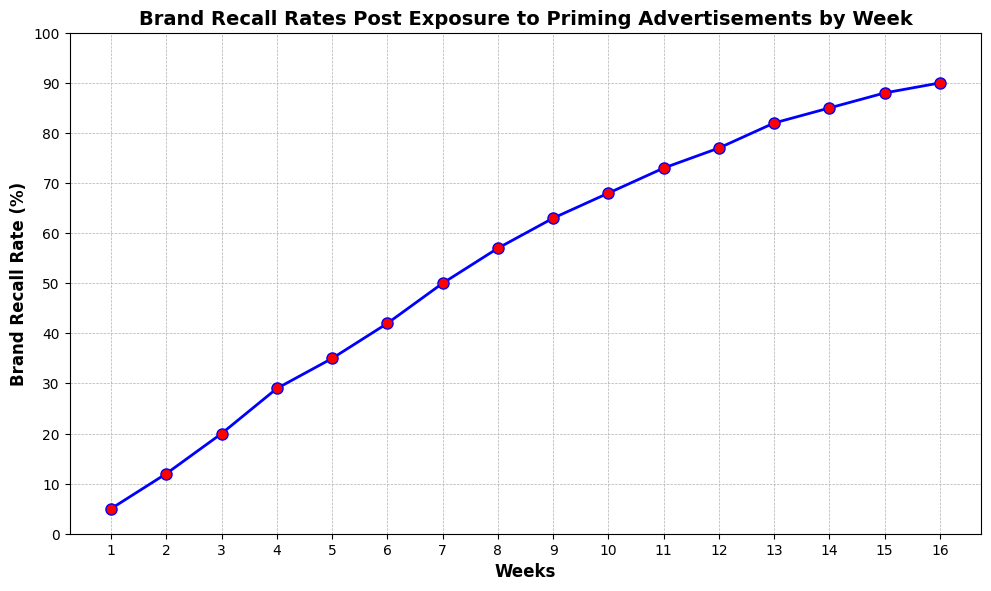What's the brand recall rate at Week 8? Look at the given point for Week 8 on the x-axis, trace upwards to find the recall rate on the y-axis and check the plotted data point
Answer: 57% Between which weeks does the brand recall rate increase the most? Calculate the differences in recall rates between each consecutive pair of weeks and identify the largest increase
Answer: Between Week 2 and Week 3 Is the brand recall rate increasing at a steady rate throughout the 16 weeks? Observe the shape of the line; a steady rate would result in a straight line, while deviations indicate varying rates of increase
Answer: No What is the total increase in brand recall rate from Week 1 to Week 16? Subtract the recall rate at Week 1 from the recall rate at Week 16, 90 - 5
Answer: 85% How much did the brand recall rate change from Week 12 to Week 13? Subtract the recall rate at Week 12 from the recall rate at Week 13, 82 - 77
Answer: 5% Between Week 5 and Week 10, by how many percentage points did the brand recall rate increase on average per week? Calculate the difference between the recall rates at Week 5 and Week 10, then divide by the number of weeks (10 - 5), average increase = (68 - 35) / 5
Answer: 6.6% Between which two consecutive weeks is the smallest increase in brand recall rate observed? Calculate differences in recall rates for each consecutive pair of weeks and find the smallest one
Answer: Between Week 15 and Week 16 How does the brand recall rate at Week 16 compare to Week 8? Locate recall rates at Weeks 16 and 8 and compare them, at Week 16 it's 90% and at Week 8 it's 57%
Answer: It's 33 percentage points higher at Week 16 Is there any week where the brand recall rate does not increase compared to the previous week? Review the line chart to see if the line is ever flat, indicating no increase in recall rate
Answer: No At which week did the brand recall rate surpass 50%? Find the week where the recall rate first exceeds 50% by tracing the line chart
Answer: Week 7 